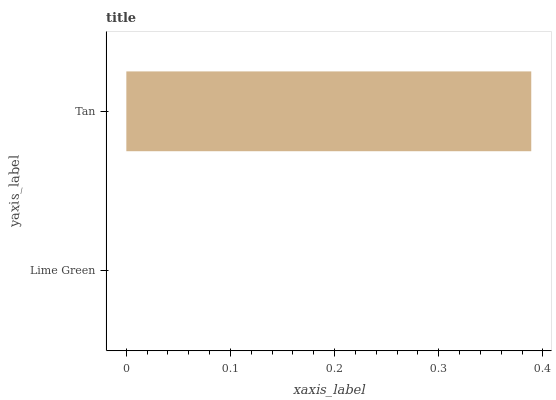Is Lime Green the minimum?
Answer yes or no. Yes. Is Tan the maximum?
Answer yes or no. Yes. Is Tan the minimum?
Answer yes or no. No. Is Tan greater than Lime Green?
Answer yes or no. Yes. Is Lime Green less than Tan?
Answer yes or no. Yes. Is Lime Green greater than Tan?
Answer yes or no. No. Is Tan less than Lime Green?
Answer yes or no. No. Is Tan the high median?
Answer yes or no. Yes. Is Lime Green the low median?
Answer yes or no. Yes. Is Lime Green the high median?
Answer yes or no. No. Is Tan the low median?
Answer yes or no. No. 